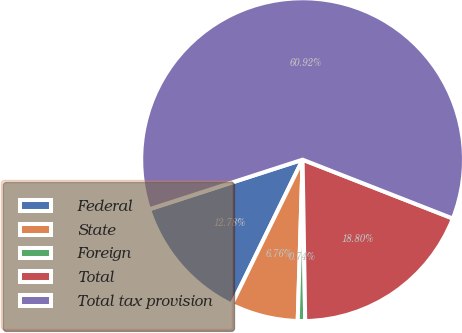Convert chart to OTSL. <chart><loc_0><loc_0><loc_500><loc_500><pie_chart><fcel>Federal<fcel>State<fcel>Foreign<fcel>Total<fcel>Total tax provision<nl><fcel>12.78%<fcel>6.76%<fcel>0.74%<fcel>18.8%<fcel>60.93%<nl></chart> 